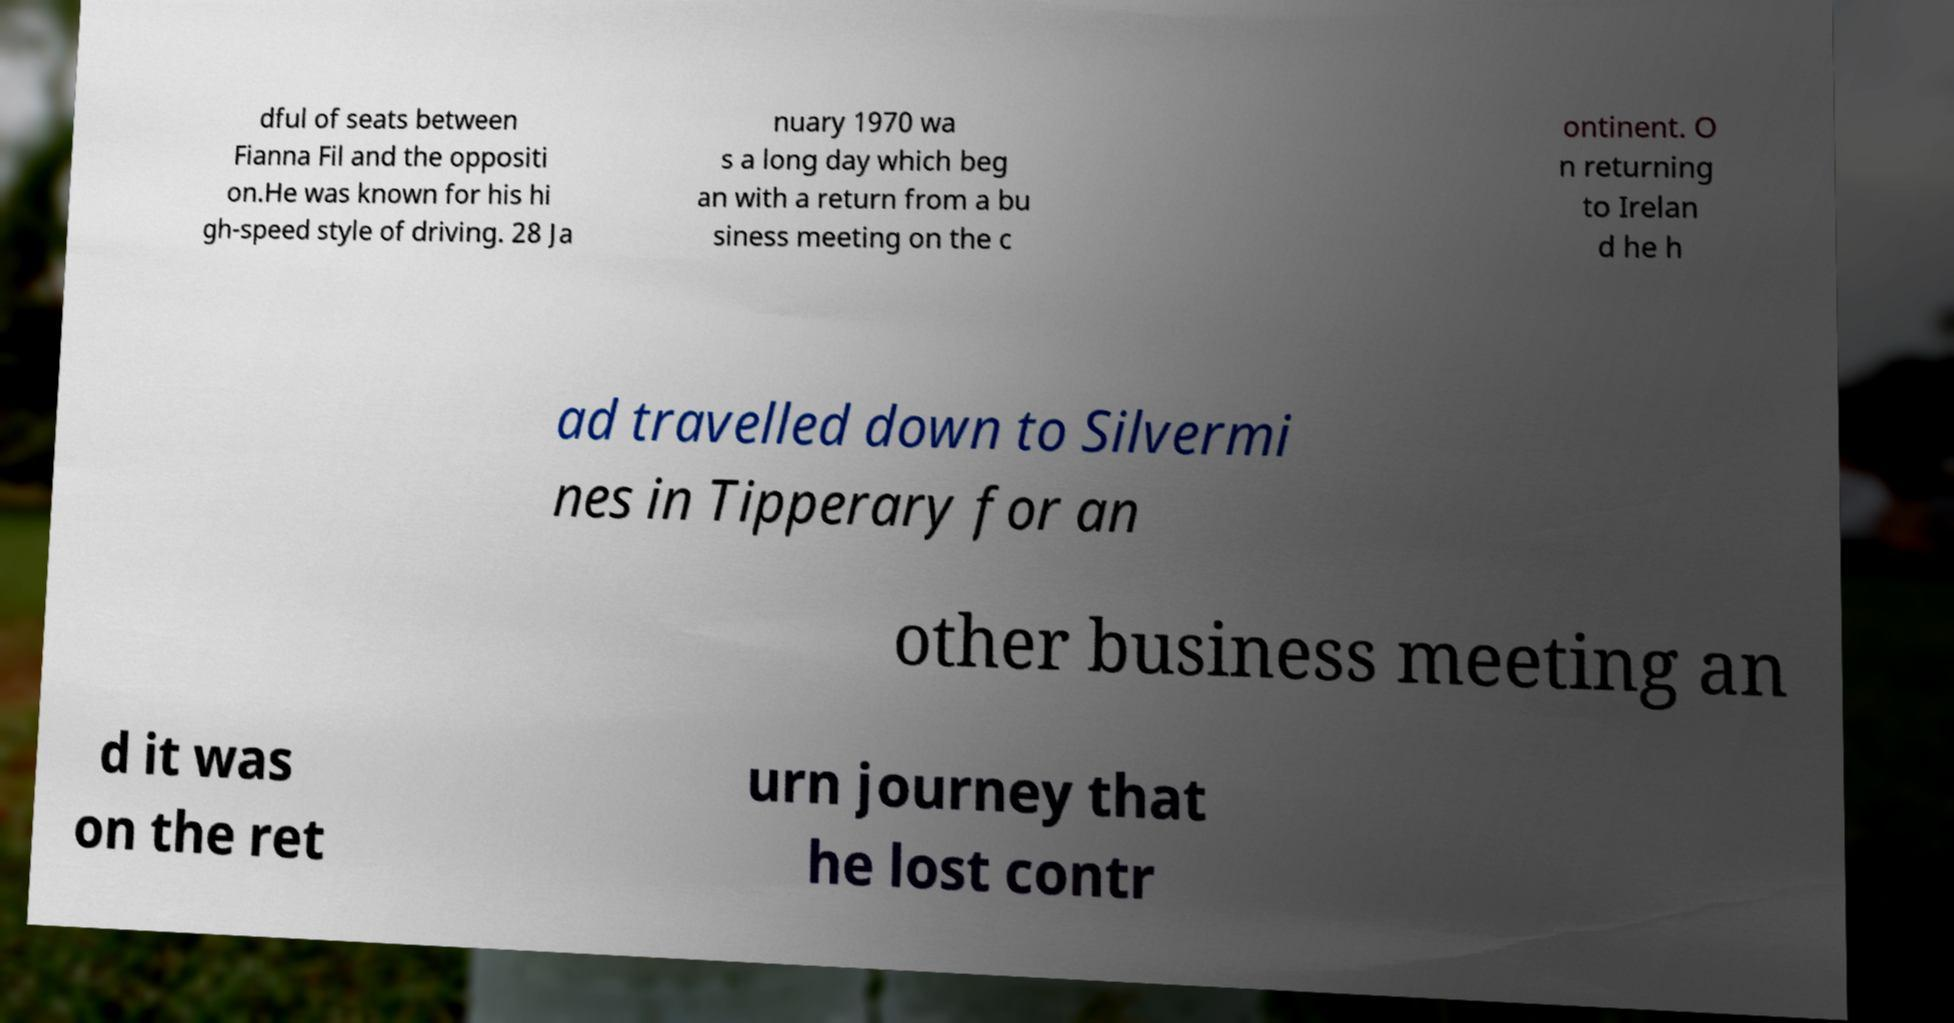Please read and relay the text visible in this image. What does it say? dful of seats between Fianna Fil and the oppositi on.He was known for his hi gh-speed style of driving. 28 Ja nuary 1970 wa s a long day which beg an with a return from a bu siness meeting on the c ontinent. O n returning to Irelan d he h ad travelled down to Silvermi nes in Tipperary for an other business meeting an d it was on the ret urn journey that he lost contr 